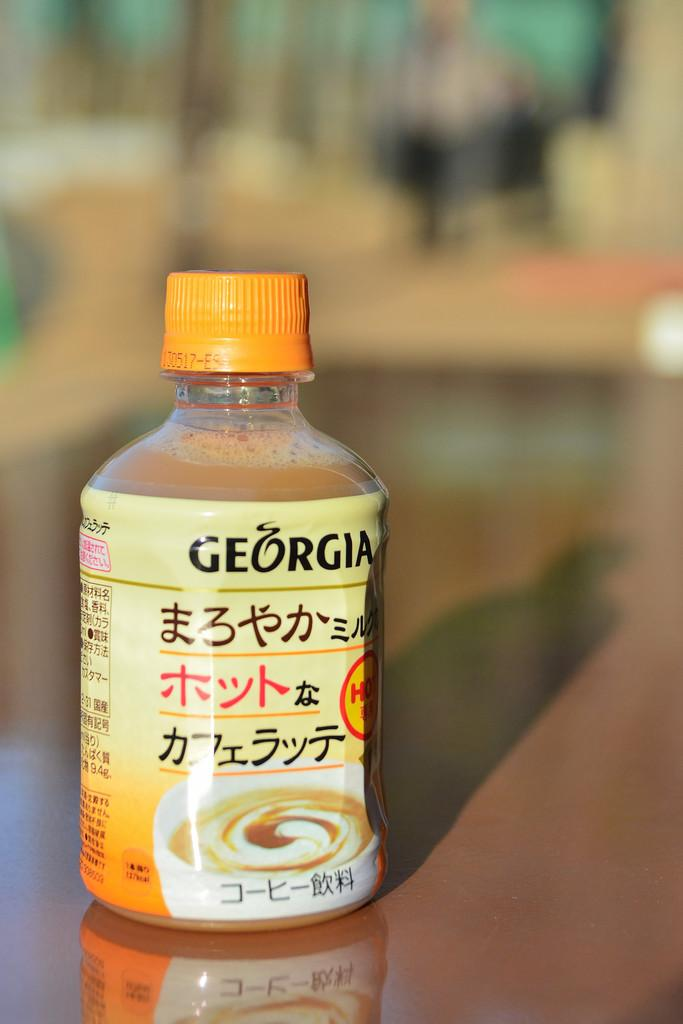<image>
Write a terse but informative summary of the picture. Coffee in a bottle from China that has Georgia on the label. 